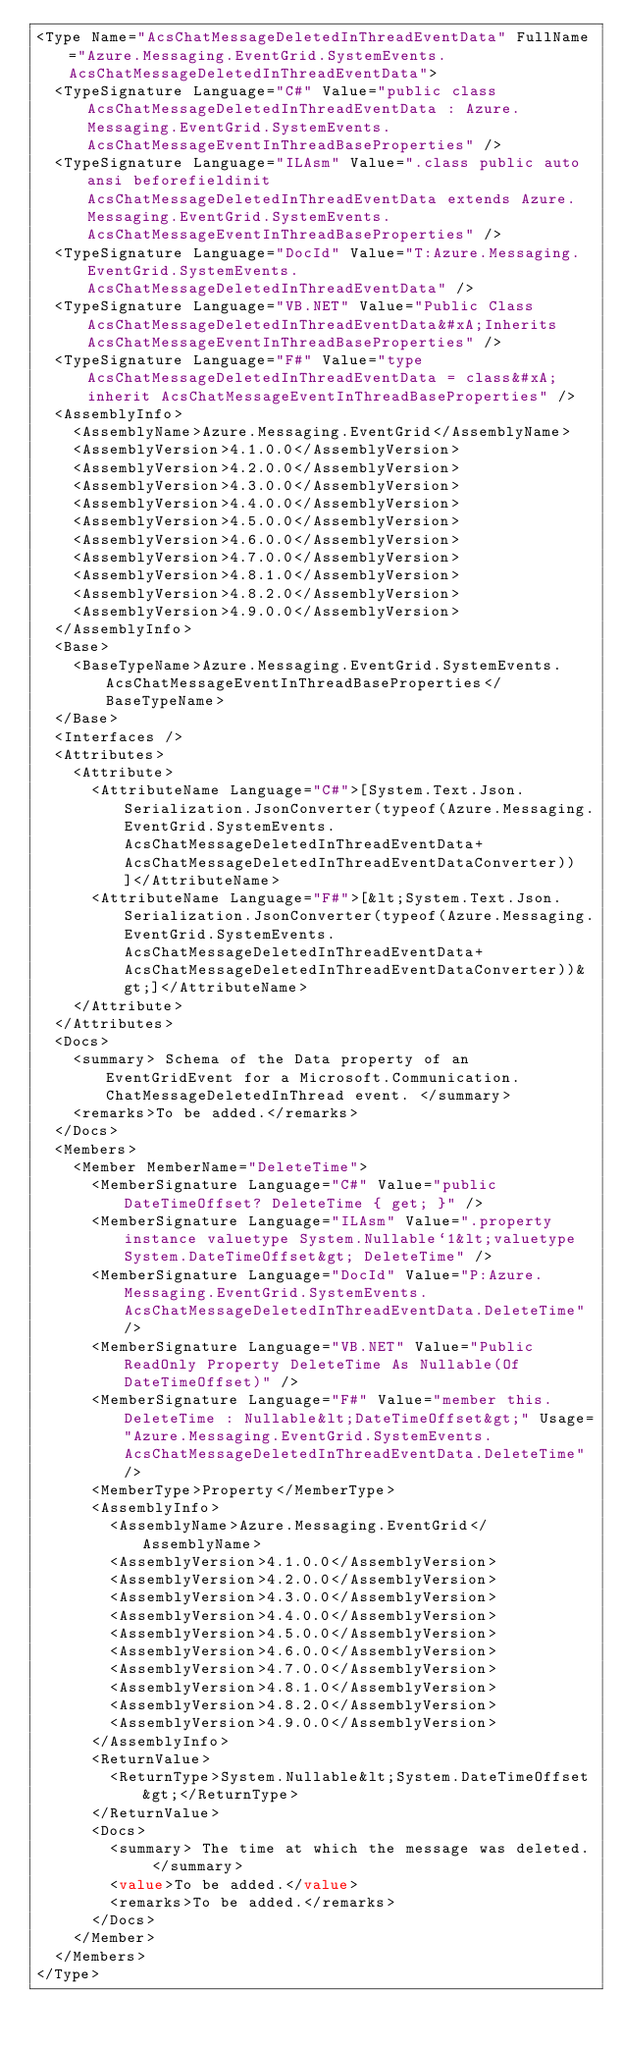Convert code to text. <code><loc_0><loc_0><loc_500><loc_500><_XML_><Type Name="AcsChatMessageDeletedInThreadEventData" FullName="Azure.Messaging.EventGrid.SystemEvents.AcsChatMessageDeletedInThreadEventData">
  <TypeSignature Language="C#" Value="public class AcsChatMessageDeletedInThreadEventData : Azure.Messaging.EventGrid.SystemEvents.AcsChatMessageEventInThreadBaseProperties" />
  <TypeSignature Language="ILAsm" Value=".class public auto ansi beforefieldinit AcsChatMessageDeletedInThreadEventData extends Azure.Messaging.EventGrid.SystemEvents.AcsChatMessageEventInThreadBaseProperties" />
  <TypeSignature Language="DocId" Value="T:Azure.Messaging.EventGrid.SystemEvents.AcsChatMessageDeletedInThreadEventData" />
  <TypeSignature Language="VB.NET" Value="Public Class AcsChatMessageDeletedInThreadEventData&#xA;Inherits AcsChatMessageEventInThreadBaseProperties" />
  <TypeSignature Language="F#" Value="type AcsChatMessageDeletedInThreadEventData = class&#xA;    inherit AcsChatMessageEventInThreadBaseProperties" />
  <AssemblyInfo>
    <AssemblyName>Azure.Messaging.EventGrid</AssemblyName>
    <AssemblyVersion>4.1.0.0</AssemblyVersion>
    <AssemblyVersion>4.2.0.0</AssemblyVersion>
    <AssemblyVersion>4.3.0.0</AssemblyVersion>
    <AssemblyVersion>4.4.0.0</AssemblyVersion>
    <AssemblyVersion>4.5.0.0</AssemblyVersion>
    <AssemblyVersion>4.6.0.0</AssemblyVersion>
    <AssemblyVersion>4.7.0.0</AssemblyVersion>
    <AssemblyVersion>4.8.1.0</AssemblyVersion>
    <AssemblyVersion>4.8.2.0</AssemblyVersion>
    <AssemblyVersion>4.9.0.0</AssemblyVersion>
  </AssemblyInfo>
  <Base>
    <BaseTypeName>Azure.Messaging.EventGrid.SystemEvents.AcsChatMessageEventInThreadBaseProperties</BaseTypeName>
  </Base>
  <Interfaces />
  <Attributes>
    <Attribute>
      <AttributeName Language="C#">[System.Text.Json.Serialization.JsonConverter(typeof(Azure.Messaging.EventGrid.SystemEvents.AcsChatMessageDeletedInThreadEventData+AcsChatMessageDeletedInThreadEventDataConverter))]</AttributeName>
      <AttributeName Language="F#">[&lt;System.Text.Json.Serialization.JsonConverter(typeof(Azure.Messaging.EventGrid.SystemEvents.AcsChatMessageDeletedInThreadEventData+AcsChatMessageDeletedInThreadEventDataConverter))&gt;]</AttributeName>
    </Attribute>
  </Attributes>
  <Docs>
    <summary> Schema of the Data property of an EventGridEvent for a Microsoft.Communication.ChatMessageDeletedInThread event. </summary>
    <remarks>To be added.</remarks>
  </Docs>
  <Members>
    <Member MemberName="DeleteTime">
      <MemberSignature Language="C#" Value="public DateTimeOffset? DeleteTime { get; }" />
      <MemberSignature Language="ILAsm" Value=".property instance valuetype System.Nullable`1&lt;valuetype System.DateTimeOffset&gt; DeleteTime" />
      <MemberSignature Language="DocId" Value="P:Azure.Messaging.EventGrid.SystemEvents.AcsChatMessageDeletedInThreadEventData.DeleteTime" />
      <MemberSignature Language="VB.NET" Value="Public ReadOnly Property DeleteTime As Nullable(Of DateTimeOffset)" />
      <MemberSignature Language="F#" Value="member this.DeleteTime : Nullable&lt;DateTimeOffset&gt;" Usage="Azure.Messaging.EventGrid.SystemEvents.AcsChatMessageDeletedInThreadEventData.DeleteTime" />
      <MemberType>Property</MemberType>
      <AssemblyInfo>
        <AssemblyName>Azure.Messaging.EventGrid</AssemblyName>
        <AssemblyVersion>4.1.0.0</AssemblyVersion>
        <AssemblyVersion>4.2.0.0</AssemblyVersion>
        <AssemblyVersion>4.3.0.0</AssemblyVersion>
        <AssemblyVersion>4.4.0.0</AssemblyVersion>
        <AssemblyVersion>4.5.0.0</AssemblyVersion>
        <AssemblyVersion>4.6.0.0</AssemblyVersion>
        <AssemblyVersion>4.7.0.0</AssemblyVersion>
        <AssemblyVersion>4.8.1.0</AssemblyVersion>
        <AssemblyVersion>4.8.2.0</AssemblyVersion>
        <AssemblyVersion>4.9.0.0</AssemblyVersion>
      </AssemblyInfo>
      <ReturnValue>
        <ReturnType>System.Nullable&lt;System.DateTimeOffset&gt;</ReturnType>
      </ReturnValue>
      <Docs>
        <summary> The time at which the message was deleted. </summary>
        <value>To be added.</value>
        <remarks>To be added.</remarks>
      </Docs>
    </Member>
  </Members>
</Type>
</code> 